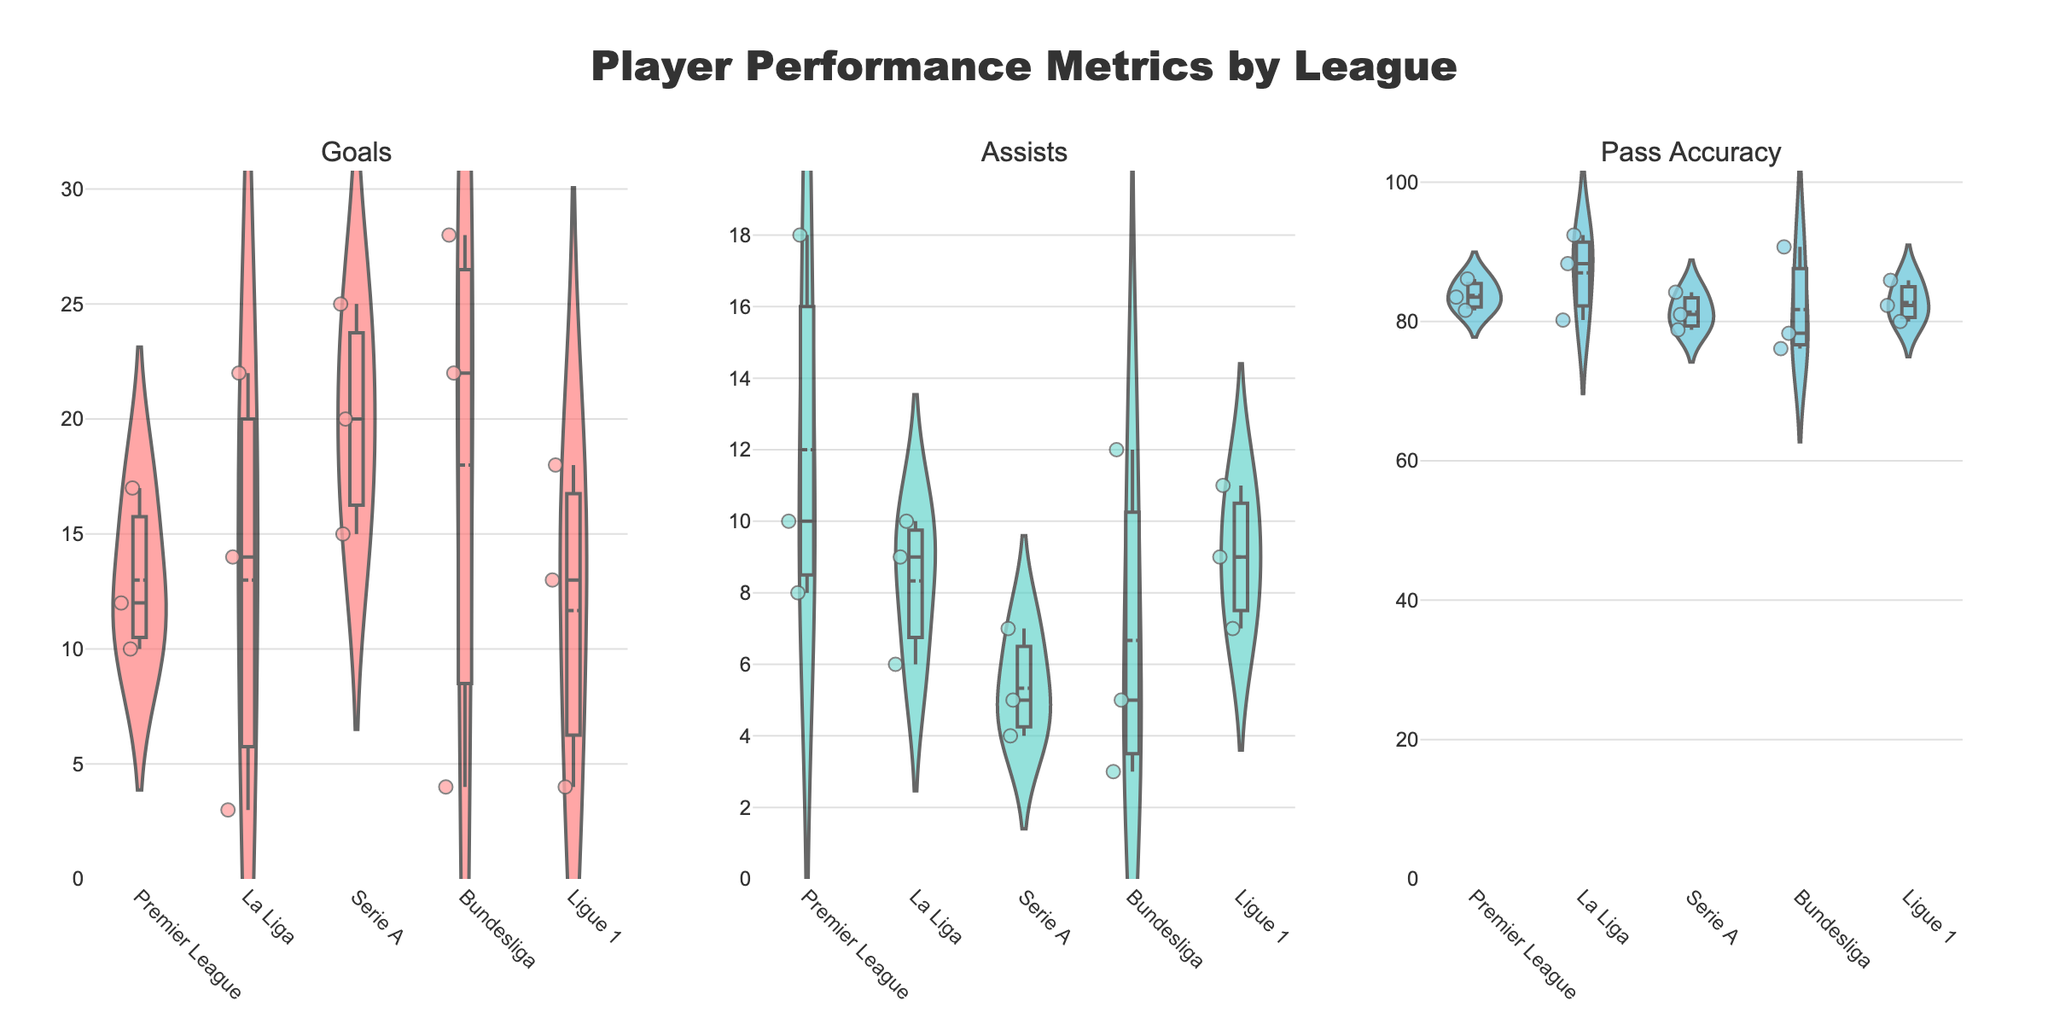How many leagues are compared in the plot? The plot has one violin chart for each league. By counting the unique categories on the x-axis, we see there are 4 leagues.
Answer: 4 Which league has the highest median number of goals? The median is the center line within each violin plot. Observing these lines, Bundesliga has the highest center line in the "Goals" subplot.
Answer: Bundesliga What is the range of assists for Premier League players? The range is found by subtracting the minimum value from the maximum value observed in the "Assists" violin plot for the Premier League. The values run from around 0 to 18.
Answer: 0 to 18 Are there any players with more than 20 goals in Serie A? In the "Goals" violin plot for Serie A, there are markers above the value of 20. By looking closely, we confirm that there are such points.
Answer: Yes Which league shows the highest standard deviation in Pass Accuracy? Standard deviation in a violin plot is reflected by the spread of the plot. La Liga has the widest spread in the "Pass Accuracy" subplot.
Answer: La Liga What is the approximate mean number of assists in Ligue 1? The mean is marked by a horizontal line in each violin plot. In the "Assists" subplot for Ligue 1, the line indicates it's around 6.5.
Answer: ~6.5 Comparing Goals, which league has the narrowest range of values? The range is the spread from minimum to maximum values within the violin plot. Serie A has the narrowest range in the "Goals" subplot.
Answer: Serie A Do players in La Liga have a higher Pass Accuracy on average compared to those in Ligue 1? By comparing the mean lines in the "Pass Accuracy" violin plots, La Liga has a higher average value than Ligue 1.
Answer: Yes Which league's players show the most variability in their assists? Variability is indicated by the spread of values in the violin plot. Premier League has the widest spread in the "Assists" subplot.
Answer: Premier League 